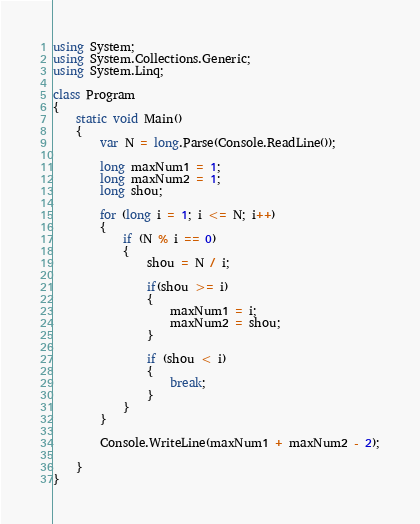Convert code to text. <code><loc_0><loc_0><loc_500><loc_500><_C#_>using System;
using System.Collections.Generic;
using System.Linq;

class Program
{
    static void Main()
    {
        var N = long.Parse(Console.ReadLine());

        long maxNum1 = 1;
        long maxNum2 = 1;
        long shou;

        for (long i = 1; i <= N; i++)
        {
            if (N % i == 0)
            {
                shou = N / i;

                if(shou >= i)
                {
                    maxNum1 = i;
                    maxNum2 = shou;
                }

                if (shou < i)
                {
                    break;
                }
            }
        }

        Console.WriteLine(maxNum1 + maxNum2 - 2);

    }
}
</code> 